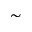<formula> <loc_0><loc_0><loc_500><loc_500>\sim</formula> 